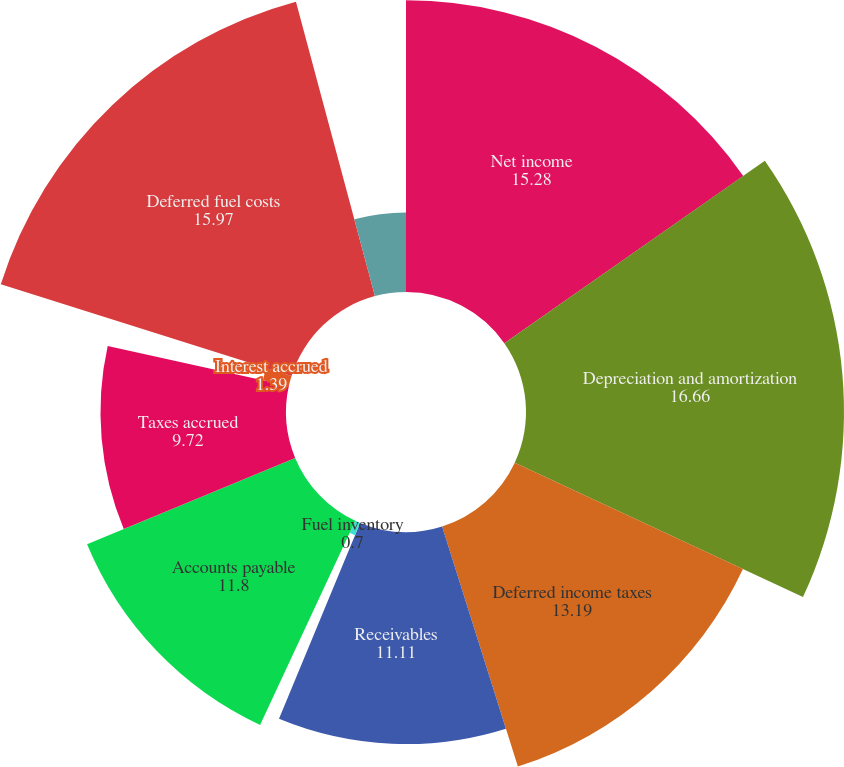<chart> <loc_0><loc_0><loc_500><loc_500><pie_chart><fcel>Net income<fcel>Depreciation and amortization<fcel>Deferred income taxes<fcel>Receivables<fcel>Fuel inventory<fcel>Accounts payable<fcel>Taxes accrued<fcel>Interest accrued<fcel>Deferred fuel costs<fcel>Other working capital accounts<nl><fcel>15.28%<fcel>16.66%<fcel>13.19%<fcel>11.11%<fcel>0.7%<fcel>11.8%<fcel>9.72%<fcel>1.39%<fcel>15.97%<fcel>4.17%<nl></chart> 